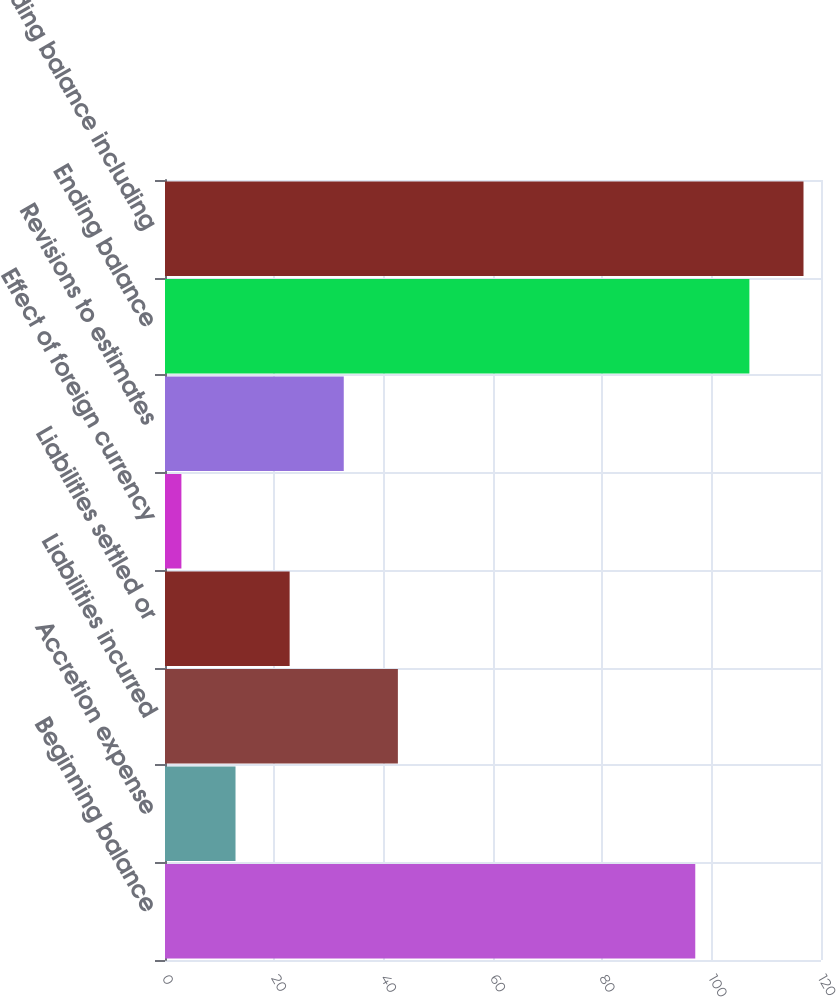Convert chart to OTSL. <chart><loc_0><loc_0><loc_500><loc_500><bar_chart><fcel>Beginning balance<fcel>Accretion expense<fcel>Liabilities incurred<fcel>Liabilities settled or<fcel>Effect of foreign currency<fcel>Revisions to estimates<fcel>Ending balance<fcel>Ending balance including<nl><fcel>97<fcel>12.9<fcel>42.6<fcel>22.8<fcel>3<fcel>32.7<fcel>106.9<fcel>116.8<nl></chart> 